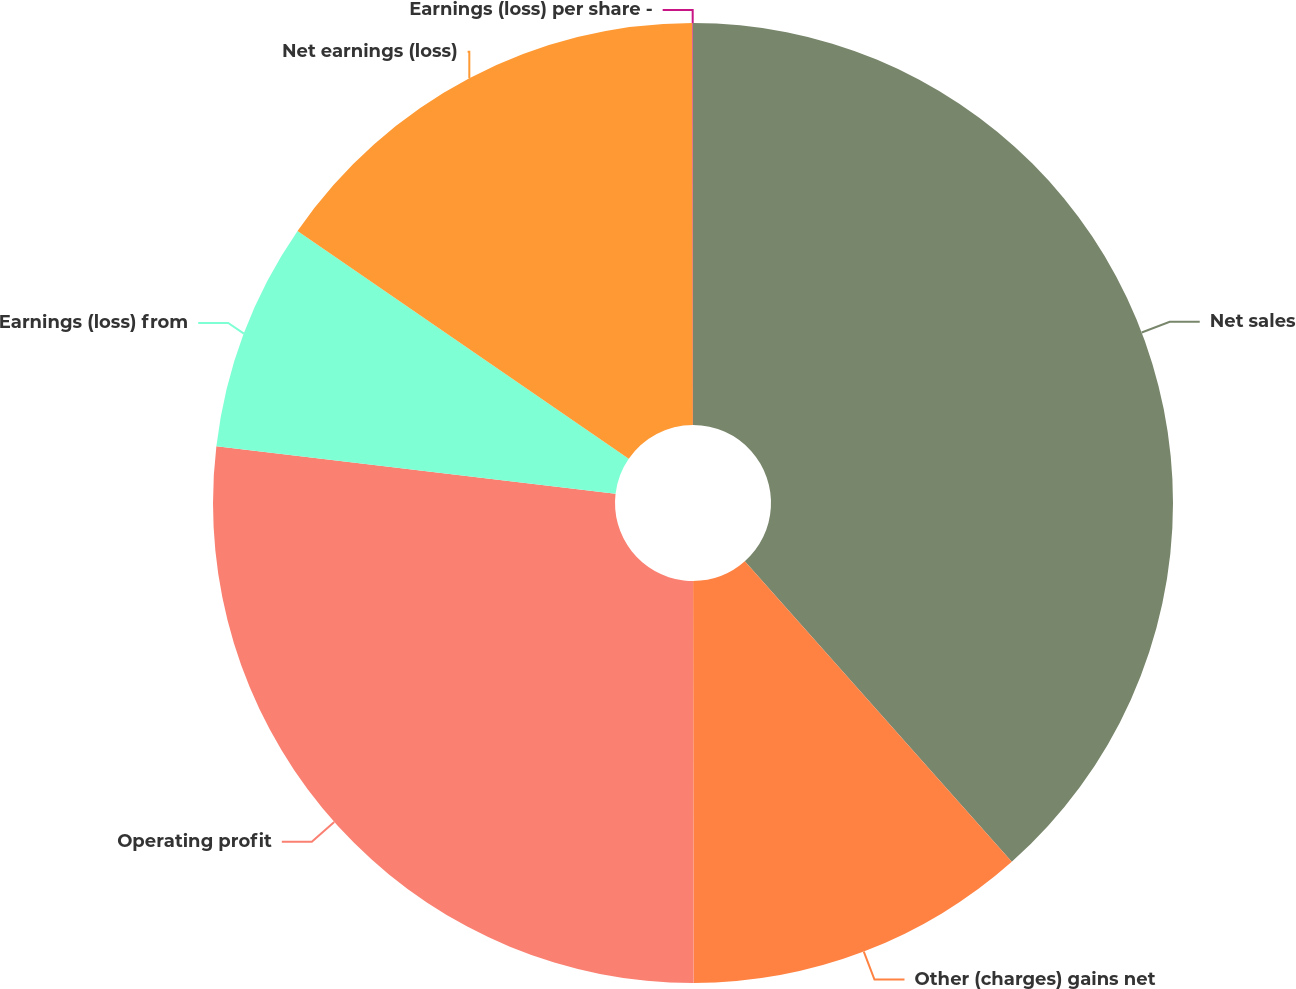Convert chart to OTSL. <chart><loc_0><loc_0><loc_500><loc_500><pie_chart><fcel>Net sales<fcel>Other (charges) gains net<fcel>Operating profit<fcel>Earnings (loss) from<fcel>Net earnings (loss)<fcel>Earnings (loss) per share -<nl><fcel>38.44%<fcel>11.54%<fcel>26.91%<fcel>7.7%<fcel>15.39%<fcel>0.02%<nl></chart> 